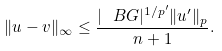<formula> <loc_0><loc_0><loc_500><loc_500>\| u - v \| _ { \infty } \leq \frac { | \ B G | ^ { 1 / { p ^ { \prime } } } \| u ^ { \prime } \| _ { p } } { n + 1 } .</formula> 